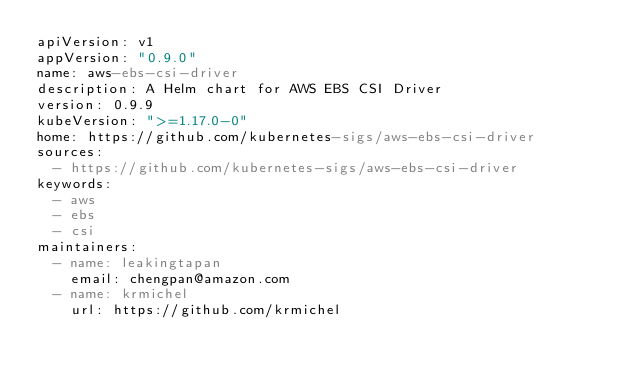Convert code to text. <code><loc_0><loc_0><loc_500><loc_500><_YAML_>apiVersion: v1
appVersion: "0.9.0"
name: aws-ebs-csi-driver
description: A Helm chart for AWS EBS CSI Driver
version: 0.9.9
kubeVersion: ">=1.17.0-0"
home: https://github.com/kubernetes-sigs/aws-ebs-csi-driver
sources:
  - https://github.com/kubernetes-sigs/aws-ebs-csi-driver
keywords:
  - aws
  - ebs
  - csi
maintainers:
  - name: leakingtapan
    email: chengpan@amazon.com
  - name: krmichel
    url: https://github.com/krmichel
</code> 